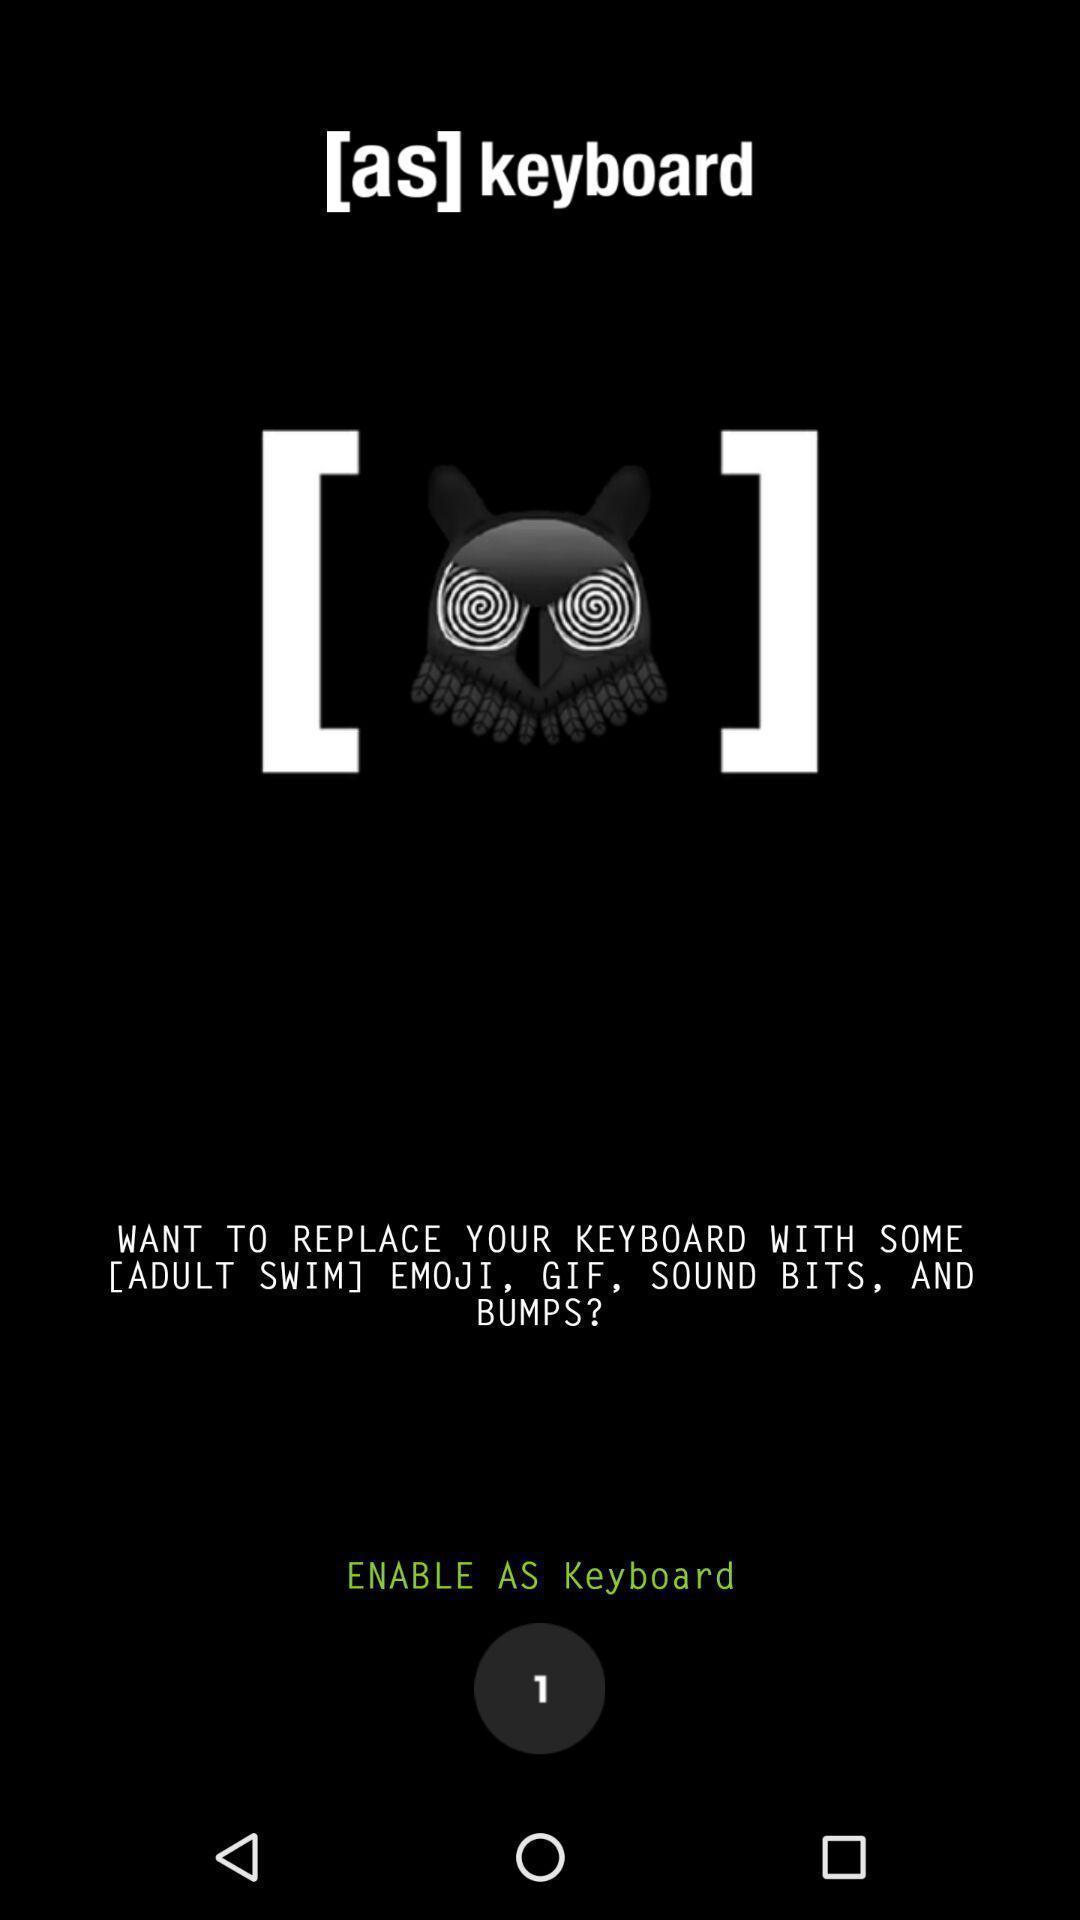Please provide a description for this image. Settings to replace keyboard with emoji. 